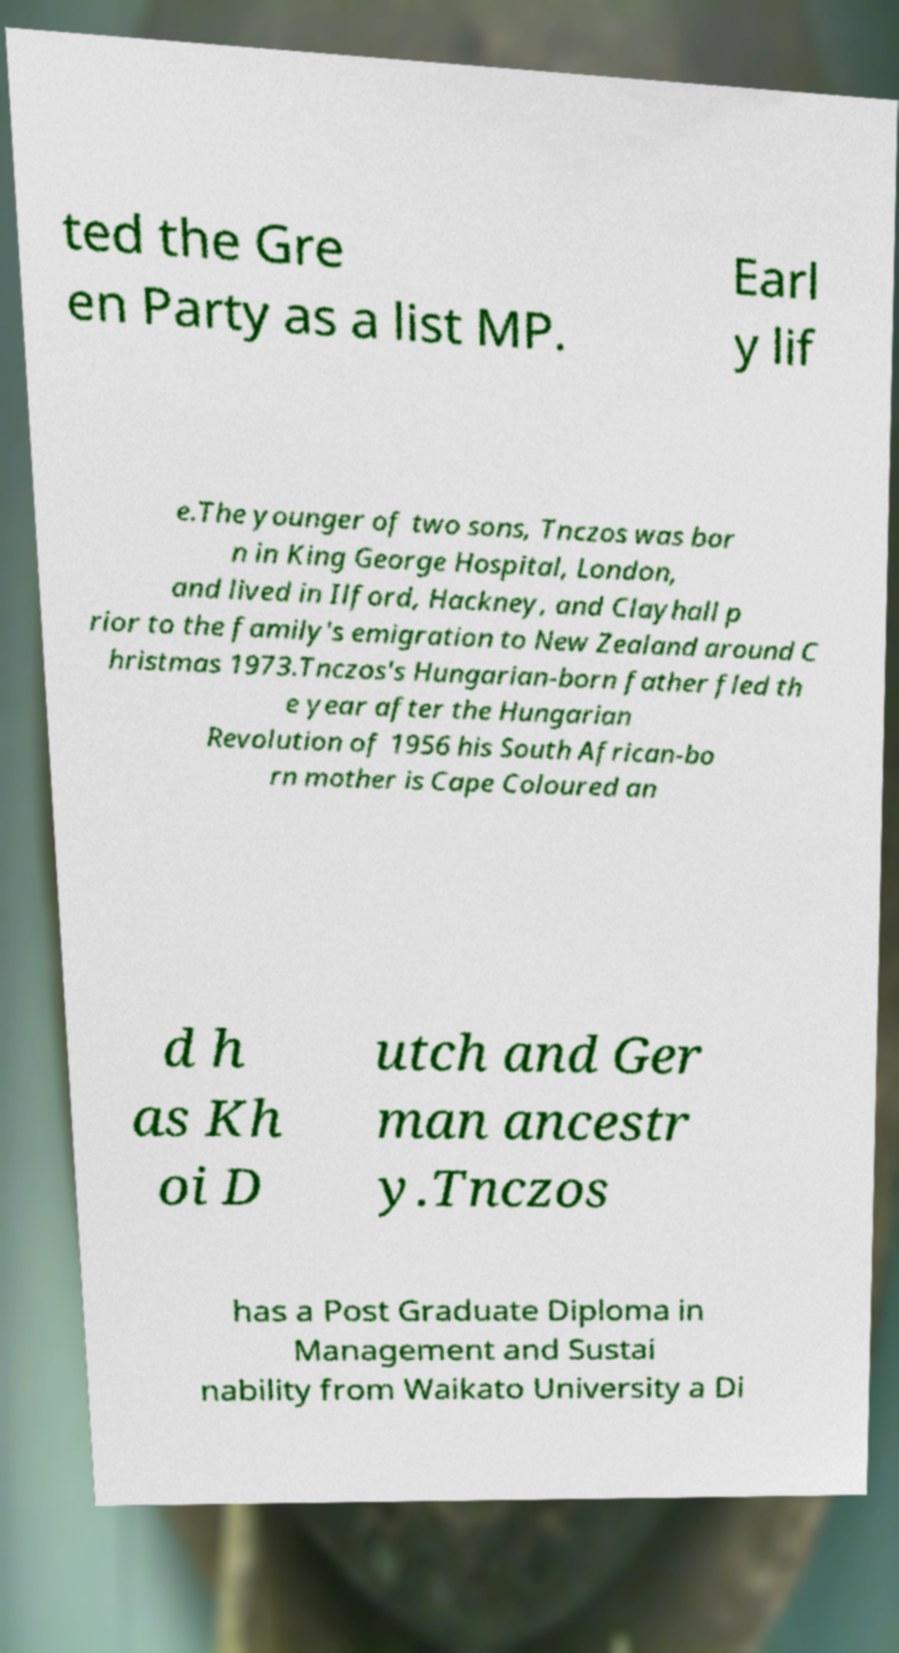Please read and relay the text visible in this image. What does it say? ted the Gre en Party as a list MP. Earl y lif e.The younger of two sons, Tnczos was bor n in King George Hospital, London, and lived in Ilford, Hackney, and Clayhall p rior to the family's emigration to New Zealand around C hristmas 1973.Tnczos's Hungarian-born father fled th e year after the Hungarian Revolution of 1956 his South African-bo rn mother is Cape Coloured an d h as Kh oi D utch and Ger man ancestr y.Tnczos has a Post Graduate Diploma in Management and Sustai nability from Waikato University a Di 